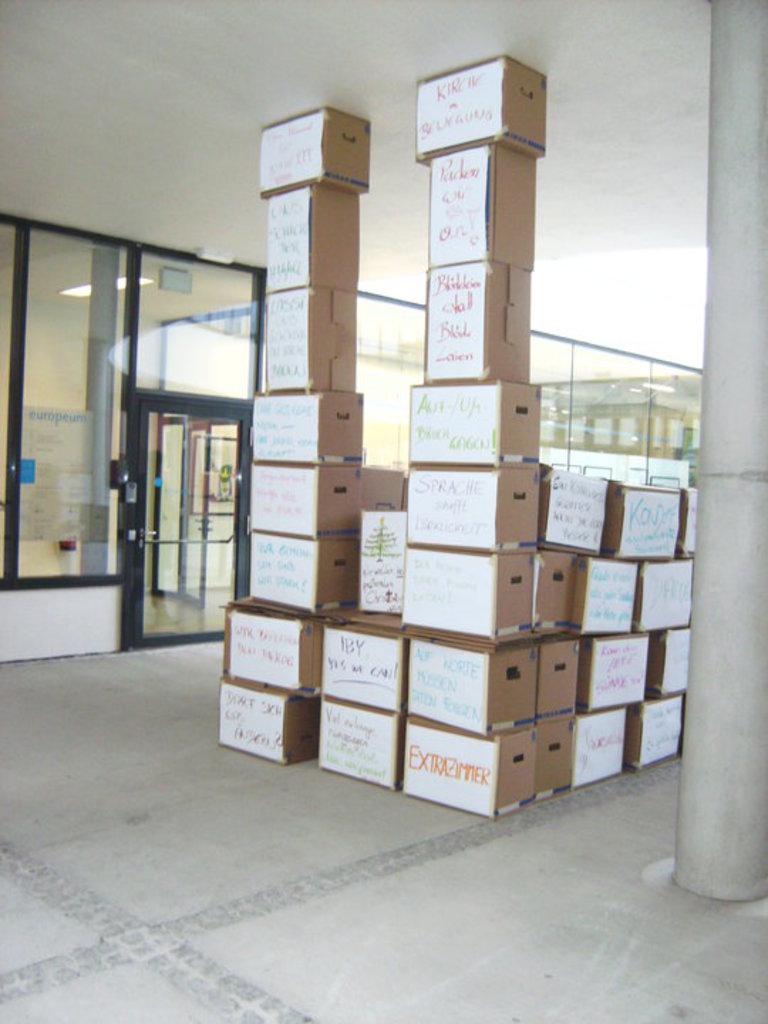What does the bottom box in orange say?
Provide a succinct answer. Extra zimmer. What is the first letter of the word on the bottom right box?
Provide a succinct answer. E. 